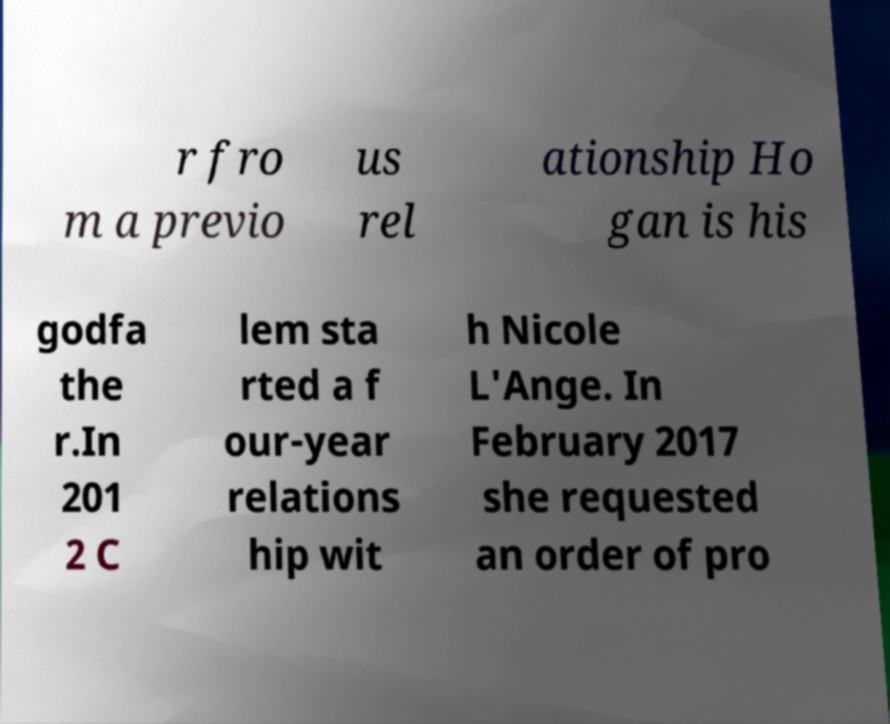Can you accurately transcribe the text from the provided image for me? r fro m a previo us rel ationship Ho gan is his godfa the r.In 201 2 C lem sta rted a f our-year relations hip wit h Nicole L'Ange. In February 2017 she requested an order of pro 